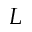<formula> <loc_0><loc_0><loc_500><loc_500>L</formula> 